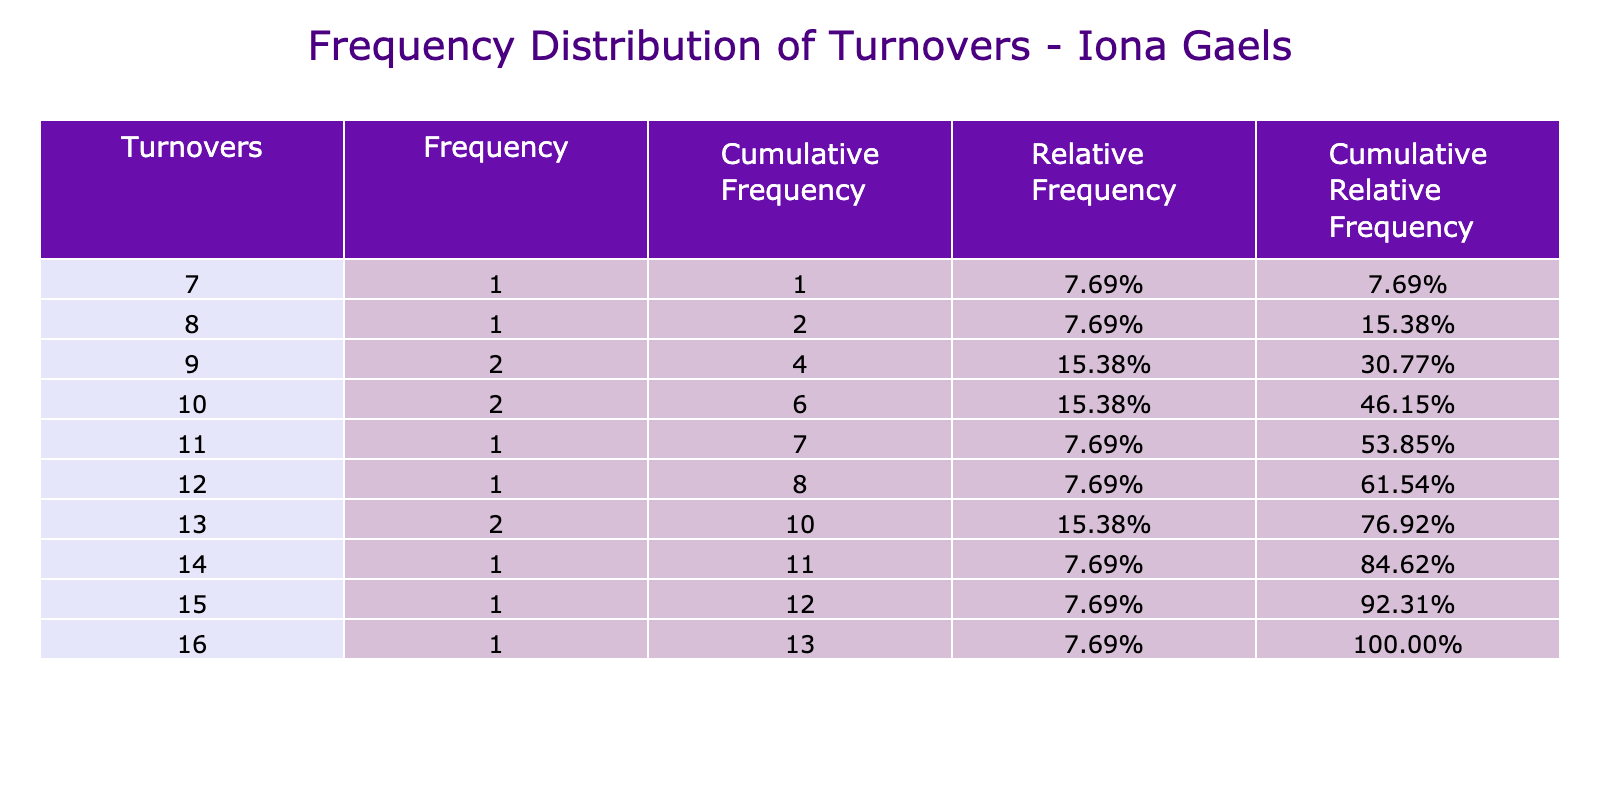What is the most common number of turnovers committed by the Iona Gaels? By looking at the frequency column, the turnover count with the highest frequency is 10, which occurred in two games against Quinnipiac Bobcats and Monmouth Hawks.
Answer: 10 What is the total frequency of games where Iona Gaels committed 12 turnovers? The frequency column shows that 12 turnovers were committed in one game against Siena Saints. Therefore, the total frequency is 1.
Answer: 1 How many games did the Iona Gaels commit more than 12 turnovers? By examining the table, we see that there are two games where the turnovers were greater than 12: 15 against Marist Red Foxes and 16 against Loyola Maryland Greyhounds. Thus, the total is 2.
Answer: 2 What is the cumulative frequency of games with 10 or fewer turnovers? To find this, we must sum the frequencies for 7, 8, 9, and 10 turnovers: 1 (7 turnovers) + 1 (8 turnovers) + 1 (9 turnovers) + 2 (10 turnovers) = 5. Therefore, the cumulative frequency is 5.
Answer: 5 Is it true that Iona Gaels had more games with turnovers less than 10 compared to 14 or more? Yes, the table shows 3 games with turnovers less than 10 (7, 8, and 9) and only 2 games with 14 or more turnovers (14 against Niagara and 16 against Loyola). Hence, the statement is true.
Answer: Yes What is the relative frequency of committing exactly 13 turnovers? The relative frequency is found by dividing the frequency of 13 turnovers (2 games) by the total number of games (14). Thus, 2/14 = 0.142857, or approximately 14.29%.
Answer: 14.29% How many games resulted in fewer turnovers than the average number of turnovers committed? First, calculate the total turnovers: (12 + 15 + 9 + 10 + 14 + 8 + 11 + 13 + 7 + 16 + 10 + 13 + 9 =  11.6 total turnovers). Average = total turnovers / number of games = 166 / 14 = 11.857. The games with fewer turnovers than the average are those with 7, 8, 9, 10 (counting games with less turnovers). Total = 5 games.
Answer: 5 